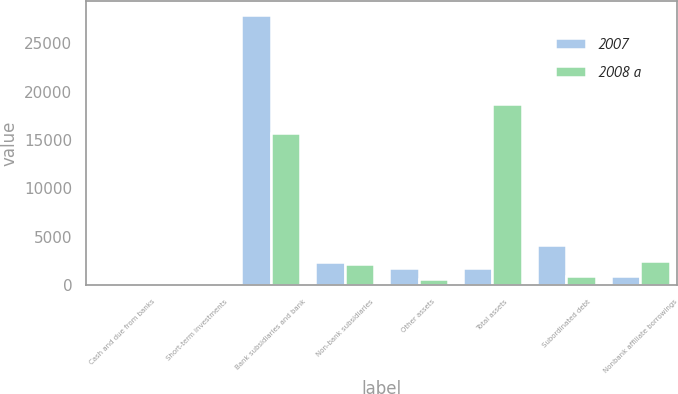Convert chart to OTSL. <chart><loc_0><loc_0><loc_500><loc_500><stacked_bar_chart><ecel><fcel>Cash and due from banks<fcel>Short-term investments<fcel>Bank subsidiaries and bank<fcel>Non-bank subsidiaries<fcel>Other assets<fcel>Total assets<fcel>Subordinated debt<fcel>Nonbank affiliate borrowings<nl><fcel>2007<fcel>15<fcel>140<fcel>27960<fcel>2378<fcel>1821<fcel>1821<fcel>4122<fcel>945<nl><fcel>2008 a<fcel>20<fcel>58<fcel>15776<fcel>2214<fcel>614<fcel>18682<fcel>968<fcel>2478<nl></chart> 